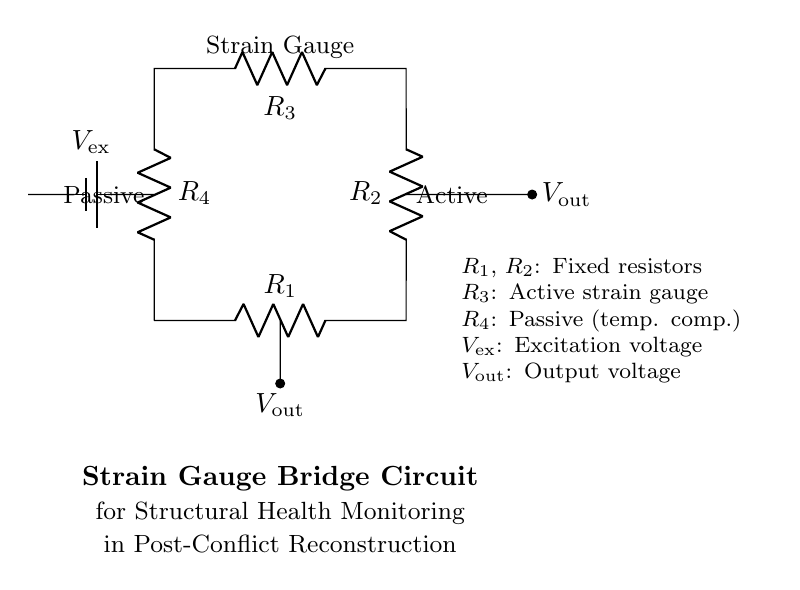What type of circuit is represented? The circuit is a bridge circuit, which is specifically configured to measure changes in resistance, commonly used with strain gauges.
Answer: bridge circuit What components are represented by R1 and R2? R1 and R2 are fixed resistors, typically used as reference resistors in the bridge configuration to compare the resistance of the strain gauge.
Answer: fixed resistors What is the role of R3 in the circuit? R3 is the active strain gauge, which changes resistance in response to mechanical strain, providing the measurement necessary for structural health monitoring.
Answer: active strain gauge What does V_ex represent in the circuit? V_ex is the excitation voltage supplied to the bridge circuit; it provides the energy necessary for the circuit to function and allows voltage output readings.
Answer: excitation voltage How does the output voltage relate to strain measurements? The output voltage, V_out, changes based on the resistance variation in R3 (the strain gauge); this voltage is directly related to the strain experienced by the structure being monitored.
Answer: related to strain What is the purpose of R4 in the circuit? R4 is a passive resistor used for temperature compensation, helping to stabilize readings and reduce errors caused by temperature fluctuations in the strain gauge.
Answer: passive (temperature compensation) What is the significance of the output voltage V_out? V_out indicates the difference in potential between the two sides of the bridge, providing a measurable signal that reflects the strain experienced by the structure.
Answer: measurable signal 